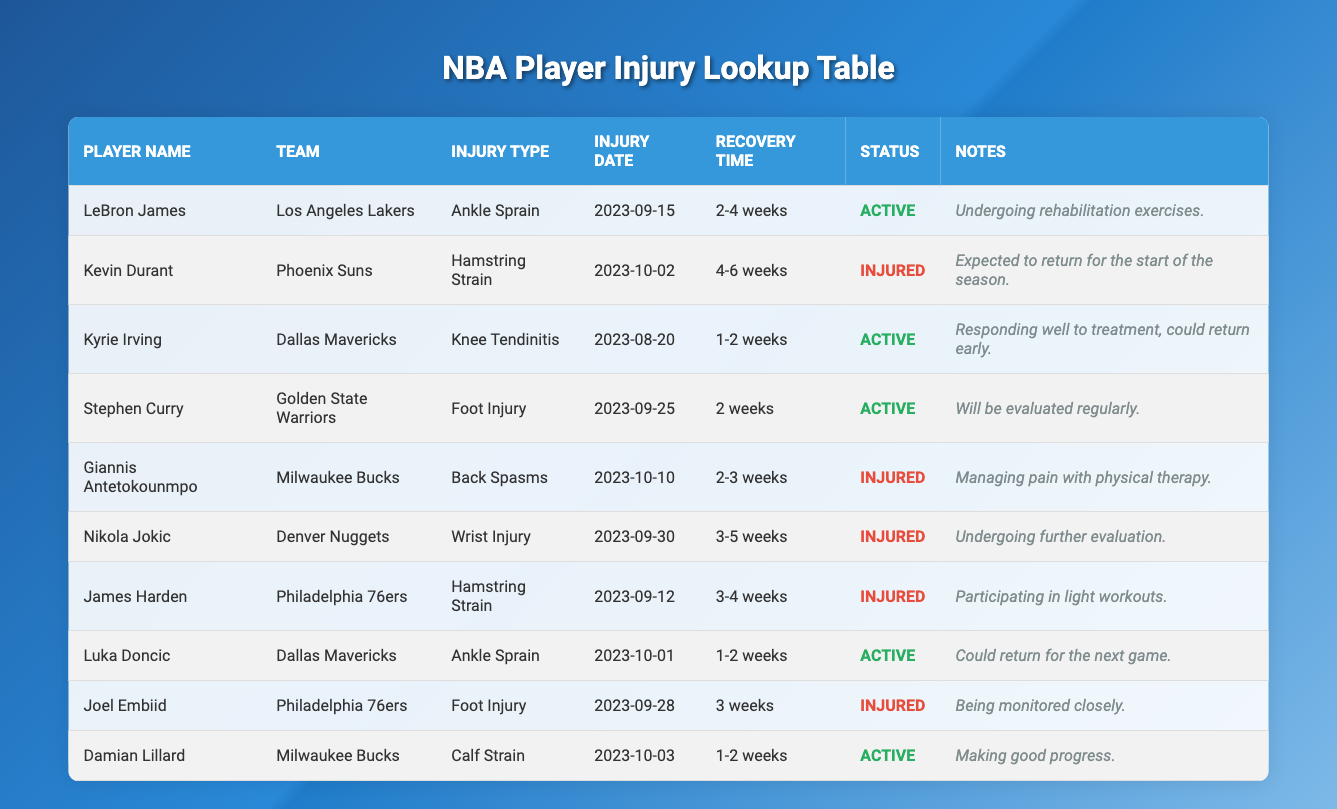What is the injury type for LeBron James? LeBron James's injury type is listed in the table under the "Injury Type" column, where it is specified as "Ankle Sprain."
Answer: Ankle Sprain What is the recovery time for Kevin Durant? Kevin Durant's recovery time can be found in the table in the "Recovery Time" column, where it states "4-6 weeks."
Answer: 4-6 weeks Which players are currently active? To determine which players are active, look at the "Status" column in the table. The players marked as "Active" are LeBron James, Kyrie Irving, Stephen Curry, Luka Doncic, and Damian Lillard.
Answer: LeBron James, Kyrie Irving, Stephen Curry, Luka Doncic, Damian Lillard How many players have a recovery time of 1-2 weeks? The "Recovery Time" column indicates that Kyrie Irving, Luka Doncic, and Damian Lillard have a recovery time of "1-2 weeks". Counting these entries gives us a total of three players.
Answer: 3 Is Giannis Antetokounmpo currently injured? The "Status" column shows "Injured" for Giannis Antetokounmpo, confirming that he is indeed currently injured.
Answer: Yes What is the average recovery time for the injured players? First, identify the injured players and their recovery times: Kevin Durant (4-6 weeks), Giannis Antetokounmpo (2-3 weeks), Nikola Jokic (3-5 weeks), James Harden (3-4 weeks), Joel Embiid (3 weeks). Converting ranges to approximate values (5 weeks for Kevin Durant, 2.5 weeks for Giannis, 4 weeks for Nikola, 3.5 weeks for Harden, and 3 weeks for Embiid) gives us (5 + 2.5 + 4 + 3.5 + 3) = 18 weeks. Dividing by 5 gives an average of 3.6 weeks.
Answer: 3.6 weeks Which team does Damian Lillard play for? Damian Lillard's team is listed in the "Team" column of the table, where it specifies "Milwaukee Bucks."
Answer: Milwaukee Bucks Are there more active players or injured players? By counting the "Status" column, we find 5 active players (LeBron James, Kyrie Irving, Stephen Curry, Luka Doncic, Damian Lillard) and 5 injured players (Kevin Durant, Giannis Antetokounmpo, Nikola Jokic, James Harden, Joel Embiid). Since both groups contain the same number of players, the answer is equal.
Answer: Equal What notes are provided for Luka Doncic? The "Notes" column contains the entry for Luka Doncic stating "Could return for the next game."
Answer: Could return for the next game 